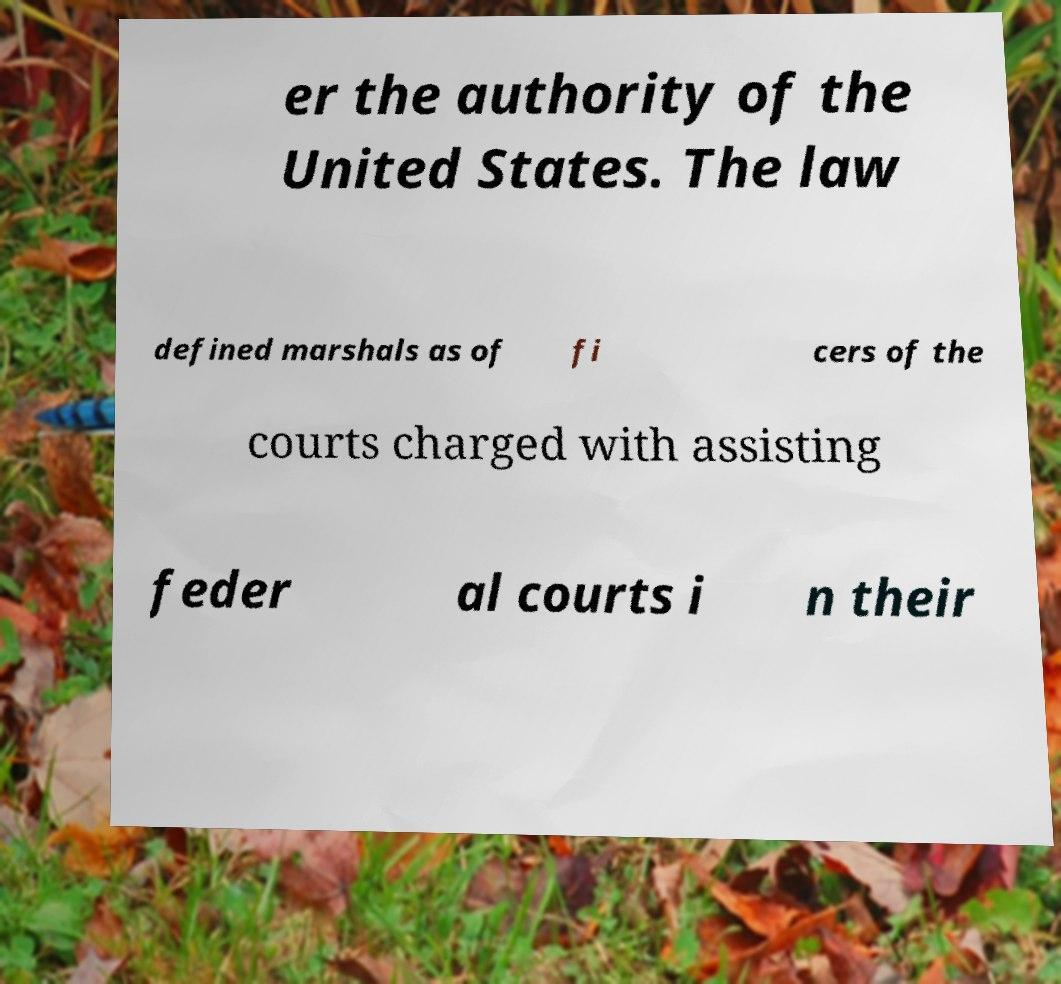Could you assist in decoding the text presented in this image and type it out clearly? er the authority of the United States. The law defined marshals as of fi cers of the courts charged with assisting feder al courts i n their 